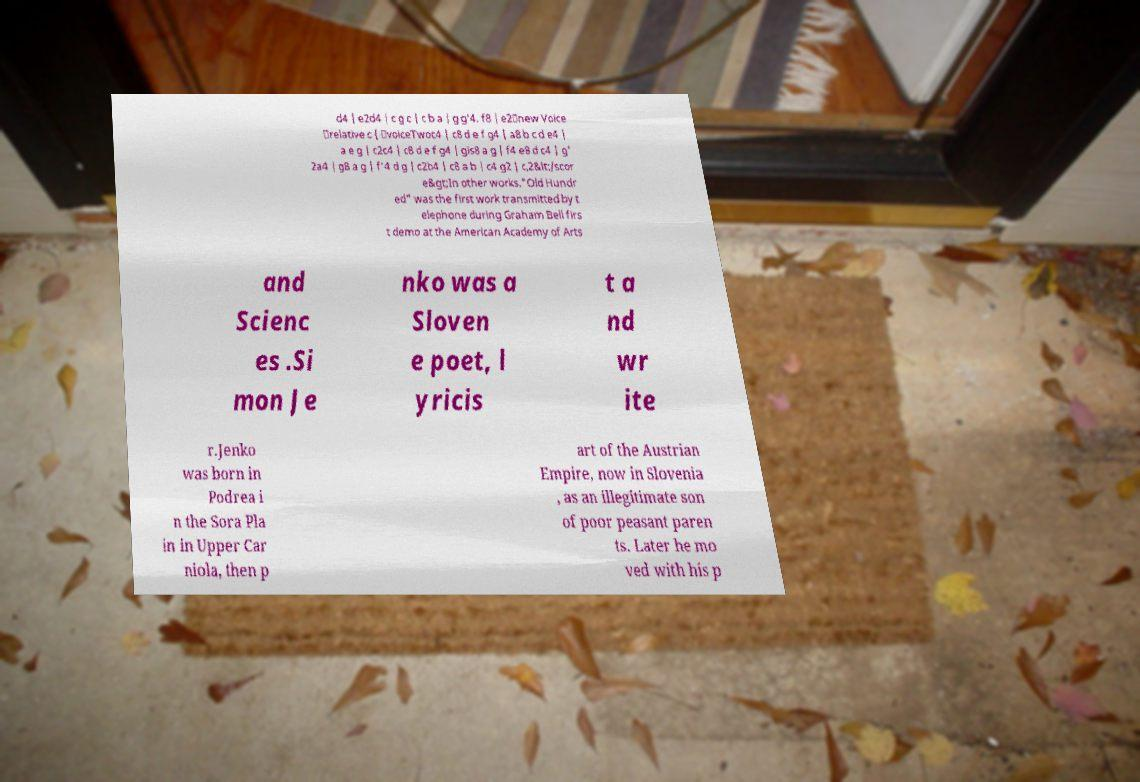Could you extract and type out the text from this image? d4 | e2d4 | c g c | c b a | g g'4. f8 | e2\new Voice \relative c { \voiceTwoc4 | c8 d e f g4 | a8 b c d e4 | a e g | c2c4 | c8 d e f g4 | gis8 a g | f4 e8 d c4 | g' 2a4 | g8 a g | f'4 d g | c2b4 | c8 a b | c4 g2 | c,2&lt;/scor e&gt;In other works."Old Hundr ed" was the first work transmitted by t elephone during Graham Bell firs t demo at the American Academy of Arts and Scienc es .Si mon Je nko was a Sloven e poet, l yricis t a nd wr ite r.Jenko was born in Podrea i n the Sora Pla in in Upper Car niola, then p art of the Austrian Empire, now in Slovenia , as an illegitimate son of poor peasant paren ts. Later he mo ved with his p 